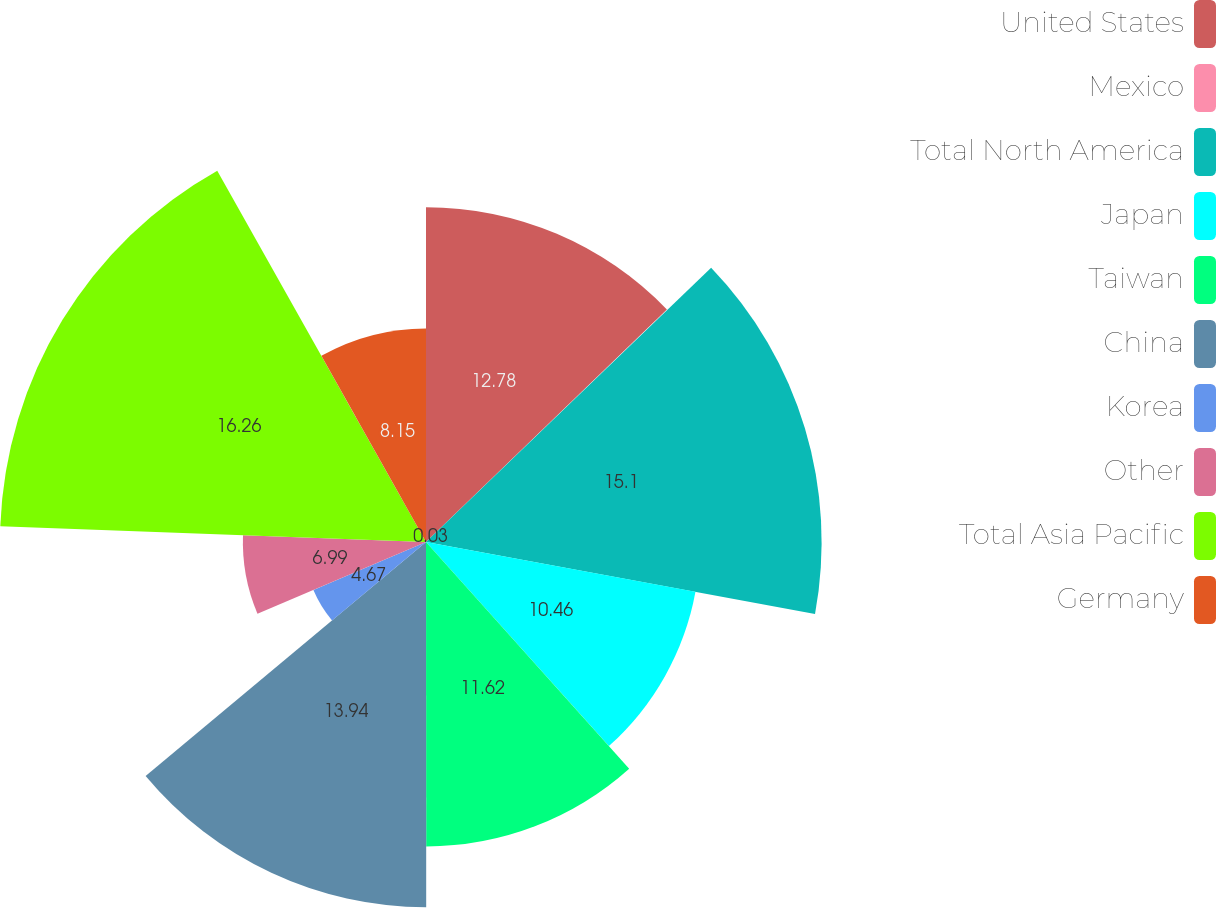<chart> <loc_0><loc_0><loc_500><loc_500><pie_chart><fcel>United States<fcel>Mexico<fcel>Total North America<fcel>Japan<fcel>Taiwan<fcel>China<fcel>Korea<fcel>Other<fcel>Total Asia Pacific<fcel>Germany<nl><fcel>12.78%<fcel>0.03%<fcel>15.1%<fcel>10.46%<fcel>11.62%<fcel>13.94%<fcel>4.67%<fcel>6.99%<fcel>16.26%<fcel>8.15%<nl></chart> 